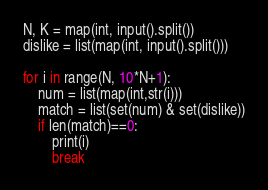Convert code to text. <code><loc_0><loc_0><loc_500><loc_500><_Python_>N, K = map(int, input().split())
dislike = list(map(int, input().split()))

for i in range(N, 10*N+1):
    num = list(map(int,str(i)))
    match = list(set(num) & set(dislike))
    if len(match)==0:
        print(i)
        break</code> 